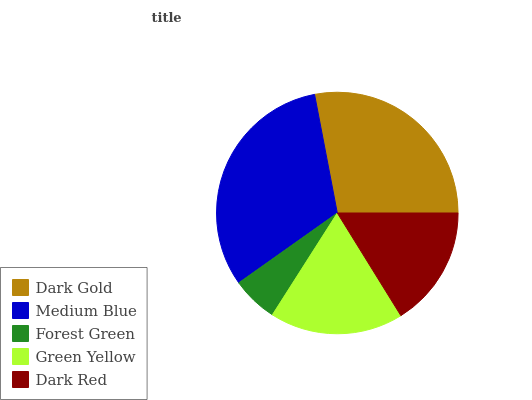Is Forest Green the minimum?
Answer yes or no. Yes. Is Medium Blue the maximum?
Answer yes or no. Yes. Is Medium Blue the minimum?
Answer yes or no. No. Is Forest Green the maximum?
Answer yes or no. No. Is Medium Blue greater than Forest Green?
Answer yes or no. Yes. Is Forest Green less than Medium Blue?
Answer yes or no. Yes. Is Forest Green greater than Medium Blue?
Answer yes or no. No. Is Medium Blue less than Forest Green?
Answer yes or no. No. Is Green Yellow the high median?
Answer yes or no. Yes. Is Green Yellow the low median?
Answer yes or no. Yes. Is Medium Blue the high median?
Answer yes or no. No. Is Forest Green the low median?
Answer yes or no. No. 